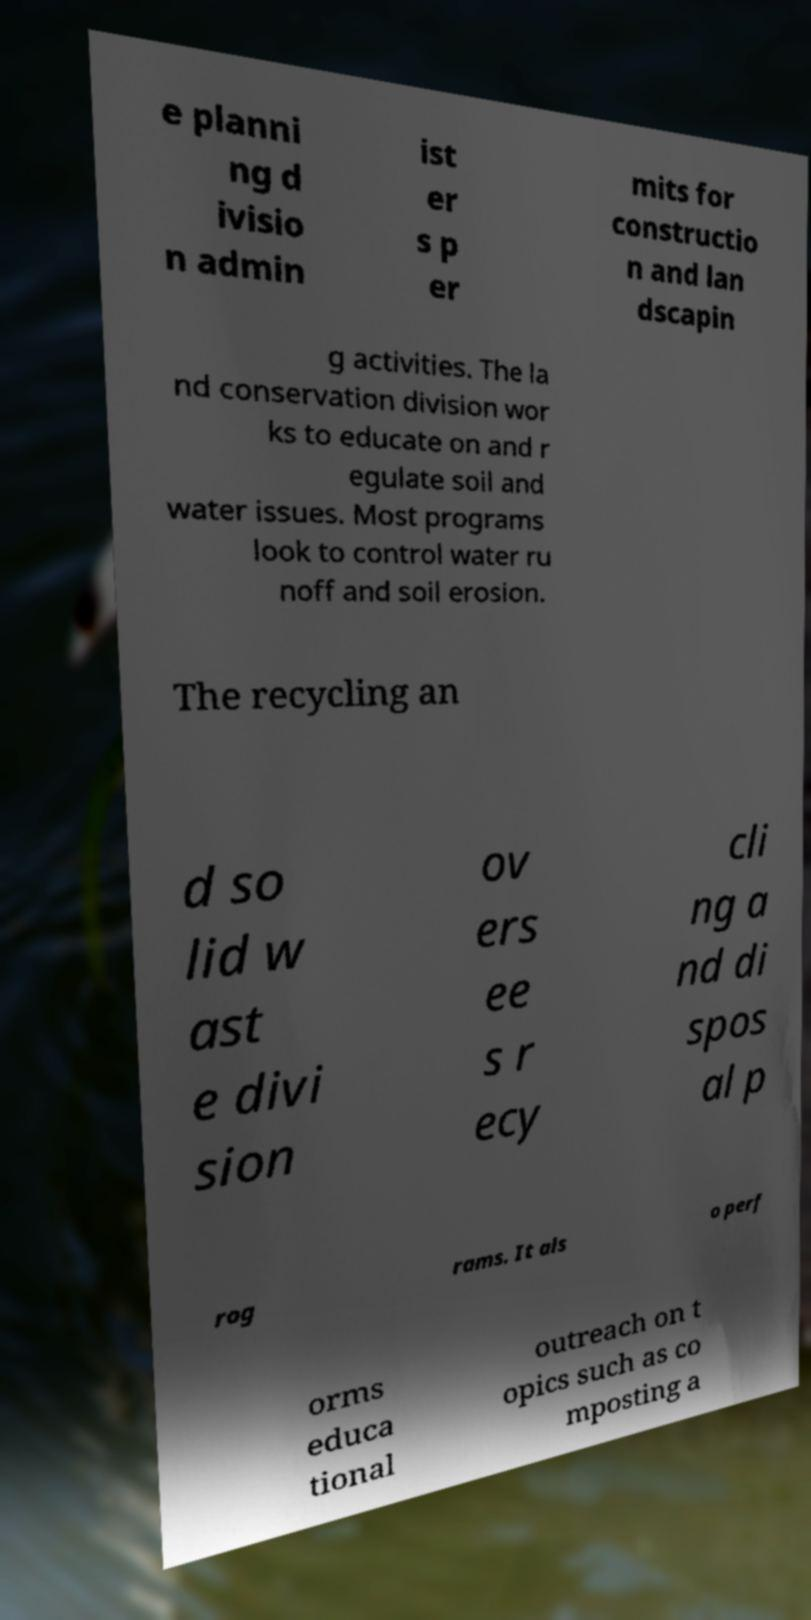Can you read and provide the text displayed in the image?This photo seems to have some interesting text. Can you extract and type it out for me? e planni ng d ivisio n admin ist er s p er mits for constructio n and lan dscapin g activities. The la nd conservation division wor ks to educate on and r egulate soil and water issues. Most programs look to control water ru noff and soil erosion. The recycling an d so lid w ast e divi sion ov ers ee s r ecy cli ng a nd di spos al p rog rams. It als o perf orms educa tional outreach on t opics such as co mposting a 